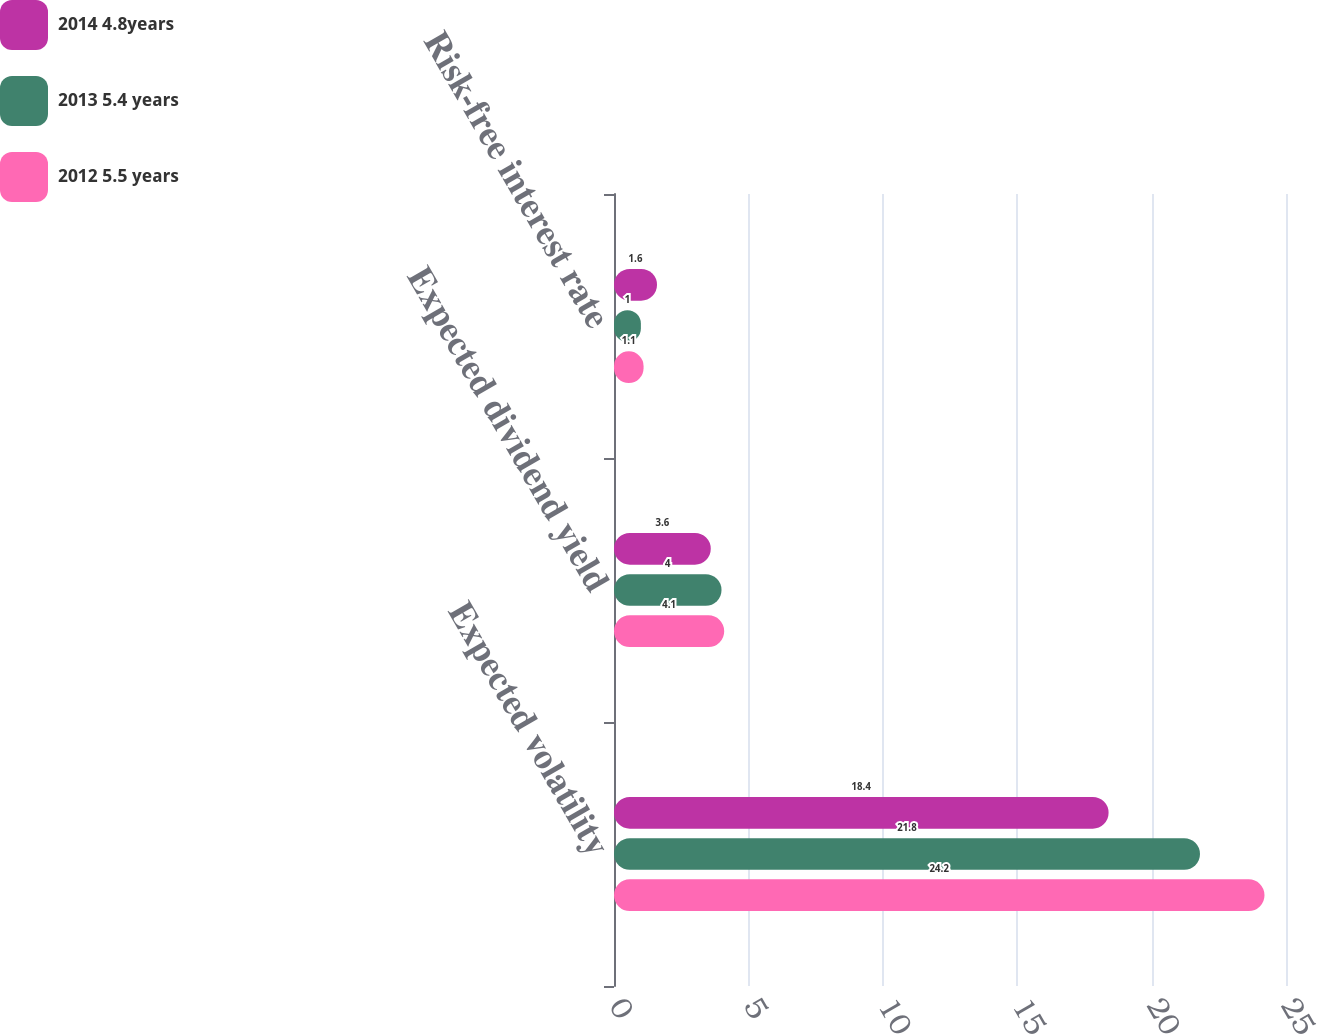Convert chart to OTSL. <chart><loc_0><loc_0><loc_500><loc_500><stacked_bar_chart><ecel><fcel>Expected volatility<fcel>Expected dividend yield<fcel>Risk-free interest rate<nl><fcel>2014 4.8years<fcel>18.4<fcel>3.6<fcel>1.6<nl><fcel>2013 5.4 years<fcel>21.8<fcel>4<fcel>1<nl><fcel>2012 5.5 years<fcel>24.2<fcel>4.1<fcel>1.1<nl></chart> 